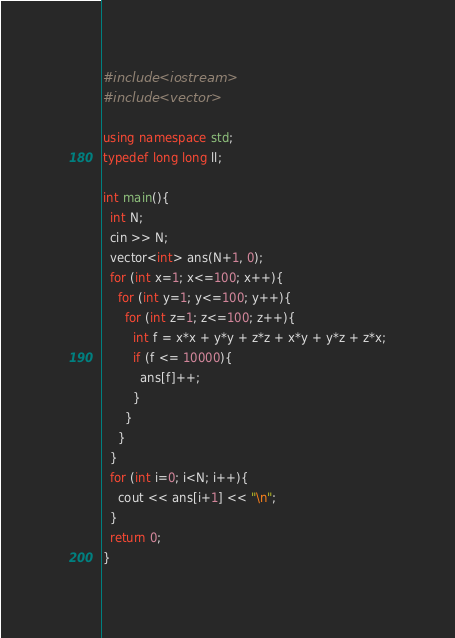<code> <loc_0><loc_0><loc_500><loc_500><_C++_>#include <iostream>
#include <vector>

using namespace std;
typedef long long ll;

int main(){
  int N;
  cin >> N;
  vector<int> ans(N+1, 0);
  for (int x=1; x<=100; x++){
    for (int y=1; y<=100; y++){
      for (int z=1; z<=100; z++){
        int f = x*x + y*y + z*z + x*y + y*z + z*x;
        if (f <= 10000){
          ans[f]++;
        }
      }
    }
  }
  for (int i=0; i<N; i++){
    cout << ans[i+1] << "\n";
  }
  return 0;
}</code> 